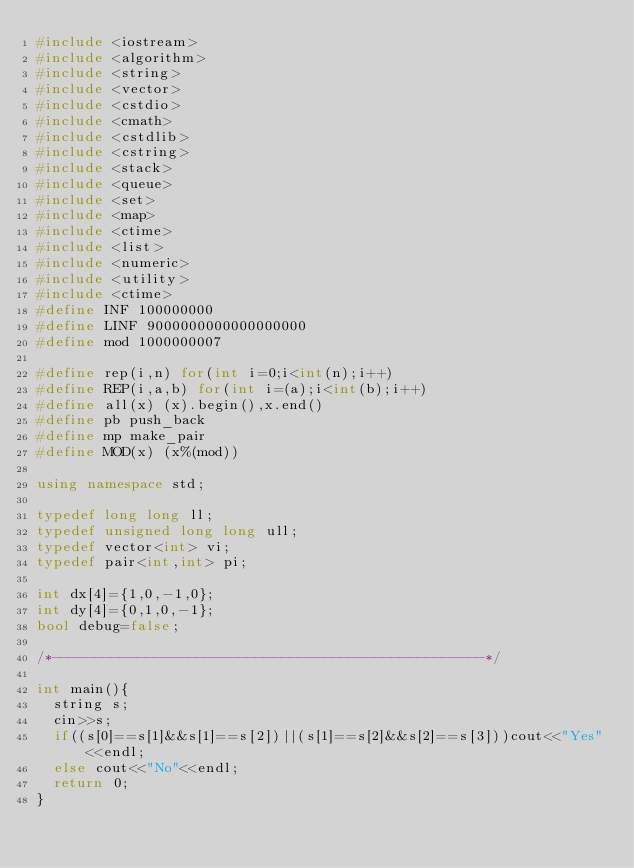<code> <loc_0><loc_0><loc_500><loc_500><_C++_>#include <iostream>
#include <algorithm>
#include <string>
#include <vector>
#include <cstdio>
#include <cmath>
#include <cstdlib>
#include <cstring>
#include <stack>
#include <queue>
#include <set>
#include <map>
#include <ctime>
#include <list>
#include <numeric>
#include <utility>
#include <ctime>
#define INF 100000000
#define LINF 9000000000000000000
#define mod 1000000007
 
#define rep(i,n) for(int i=0;i<int(n);i++)
#define REP(i,a,b) for(int i=(a);i<int(b);i++)
#define all(x) (x).begin(),x.end()
#define pb push_back
#define mp make_pair
#define MOD(x) (x%(mod))
 
using namespace std;
 
typedef long long ll;
typedef unsigned long long ull;
typedef vector<int> vi;
typedef pair<int,int> pi;
 
int dx[4]={1,0,-1,0};
int dy[4]={0,1,0,-1};
bool debug=false;
 
/*---------------------------------------------------*/
 
int main(){
  string s;
  cin>>s;
  if((s[0]==s[1]&&s[1]==s[2])||(s[1]==s[2]&&s[2]==s[3]))cout<<"Yes"<<endl;
  else cout<<"No"<<endl;
  return 0;
}</code> 